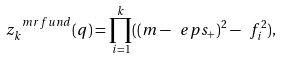Convert formula to latex. <formula><loc_0><loc_0><loc_500><loc_500>z _ { k } ^ { \ m r { f u n d } } ( q ) = \prod _ { i = 1 } ^ { k } ( ( m - \ e p s _ { + } ) ^ { 2 } - \ f _ { i } ^ { 2 } ) ,</formula> 